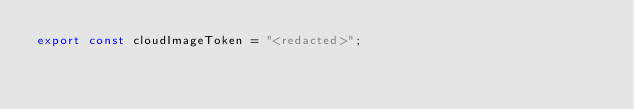Convert code to text. <code><loc_0><loc_0><loc_500><loc_500><_TypeScript_>export const cloudImageToken = "<redacted>";
</code> 